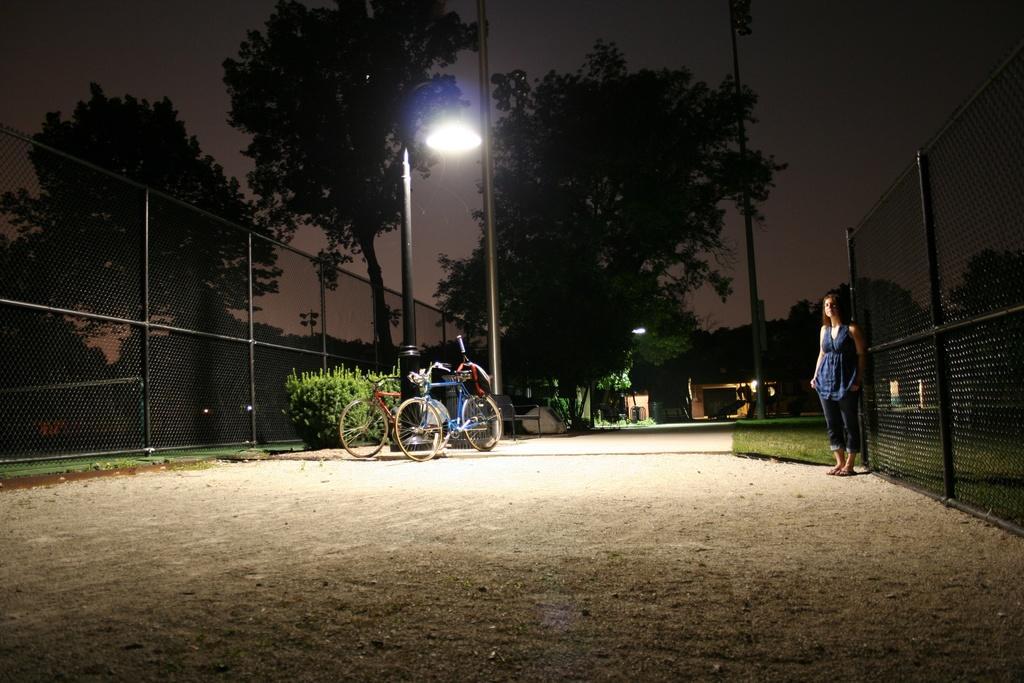Can you describe this image briefly? In the foreground I can see a fence, plants, two bicycles and a woman is standing on the road. In the background I can see trees, light poles and the sky. This image is taken during night. 